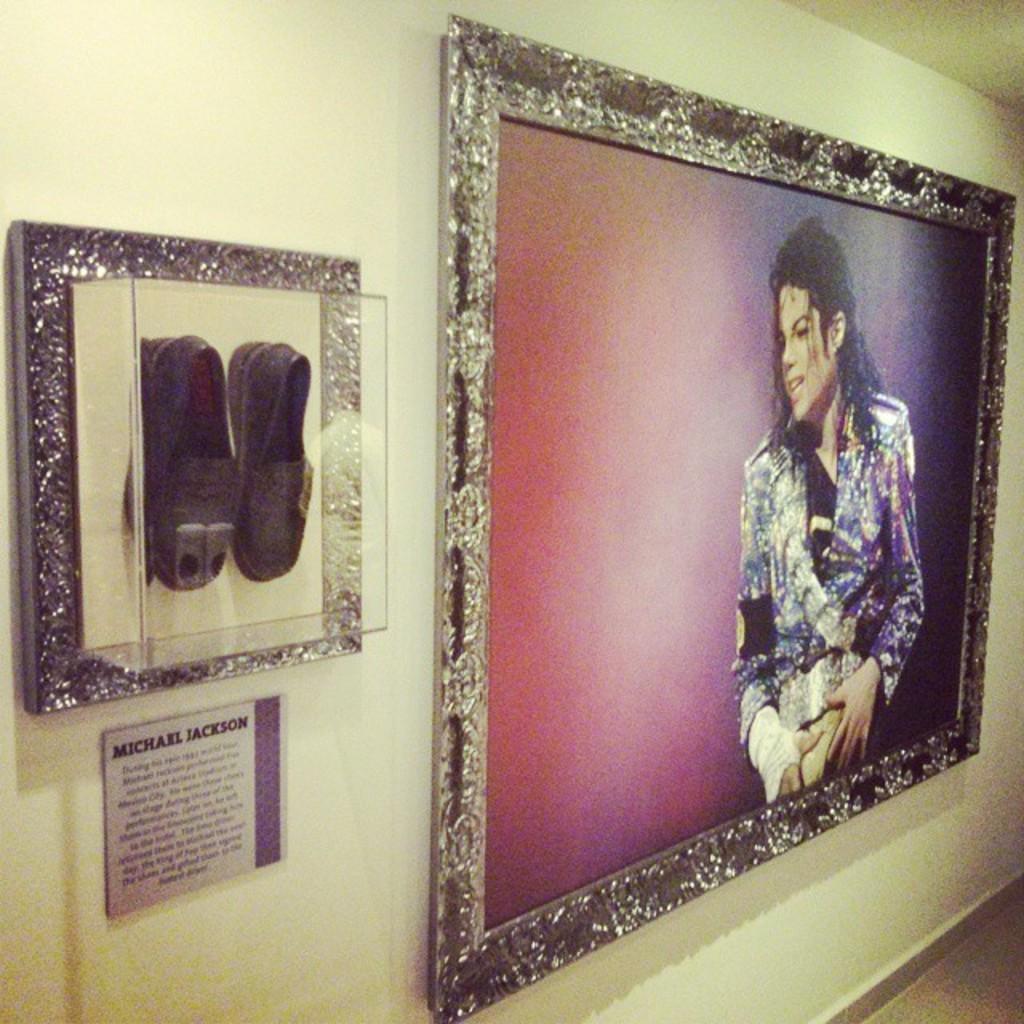Describe this image in one or two sentences. In this picture I can see the photo frame on the wall. I can see the shoes in the glass box. 